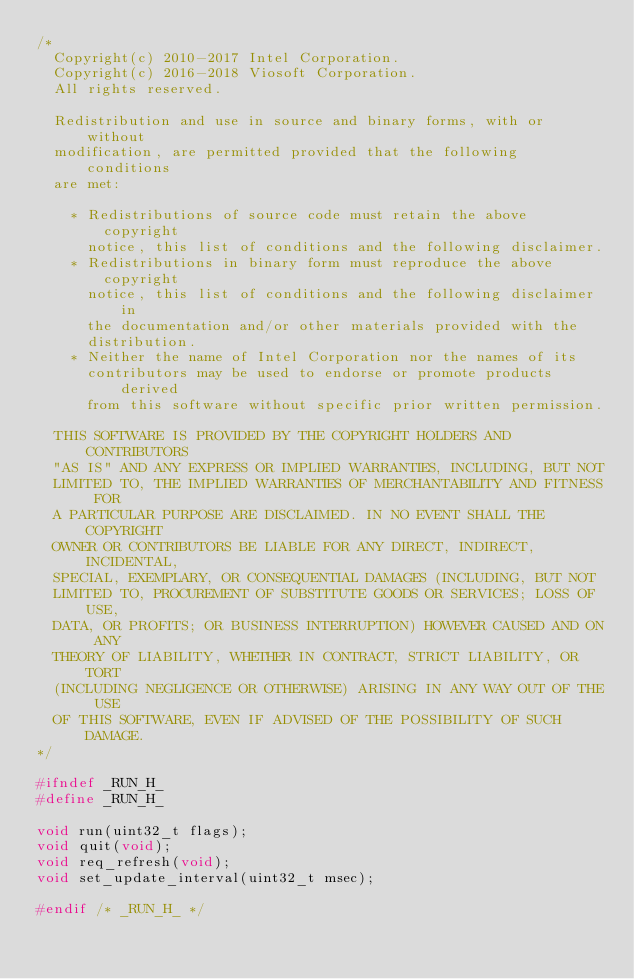Convert code to text. <code><loc_0><loc_0><loc_500><loc_500><_C_>/*
  Copyright(c) 2010-2017 Intel Corporation.
  Copyright(c) 2016-2018 Viosoft Corporation.
  All rights reserved.

  Redistribution and use in source and binary forms, with or without
  modification, are permitted provided that the following conditions
  are met:

    * Redistributions of source code must retain the above copyright
      notice, this list of conditions and the following disclaimer.
    * Redistributions in binary form must reproduce the above copyright
      notice, this list of conditions and the following disclaimer in
      the documentation and/or other materials provided with the
      distribution.
    * Neither the name of Intel Corporation nor the names of its
      contributors may be used to endorse or promote products derived
      from this software without specific prior written permission.

  THIS SOFTWARE IS PROVIDED BY THE COPYRIGHT HOLDERS AND CONTRIBUTORS
  "AS IS" AND ANY EXPRESS OR IMPLIED WARRANTIES, INCLUDING, BUT NOT
  LIMITED TO, THE IMPLIED WARRANTIES OF MERCHANTABILITY AND FITNESS FOR
  A PARTICULAR PURPOSE ARE DISCLAIMED. IN NO EVENT SHALL THE COPYRIGHT
  OWNER OR CONTRIBUTORS BE LIABLE FOR ANY DIRECT, INDIRECT, INCIDENTAL,
  SPECIAL, EXEMPLARY, OR CONSEQUENTIAL DAMAGES (INCLUDING, BUT NOT
  LIMITED TO, PROCUREMENT OF SUBSTITUTE GOODS OR SERVICES; LOSS OF USE,
  DATA, OR PROFITS; OR BUSINESS INTERRUPTION) HOWEVER CAUSED AND ON ANY
  THEORY OF LIABILITY, WHETHER IN CONTRACT, STRICT LIABILITY, OR TORT
  (INCLUDING NEGLIGENCE OR OTHERWISE) ARISING IN ANY WAY OUT OF THE USE
  OF THIS SOFTWARE, EVEN IF ADVISED OF THE POSSIBILITY OF SUCH DAMAGE.
*/

#ifndef _RUN_H_
#define _RUN_H_

void run(uint32_t flags);
void quit(void);
void req_refresh(void);
void set_update_interval(uint32_t msec);

#endif /* _RUN_H_ */
</code> 